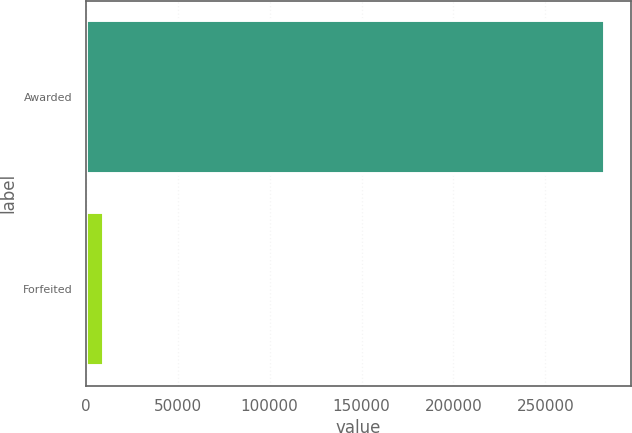Convert chart. <chart><loc_0><loc_0><loc_500><loc_500><bar_chart><fcel>Awarded<fcel>Forfeited<nl><fcel>282423<fcel>10000<nl></chart> 